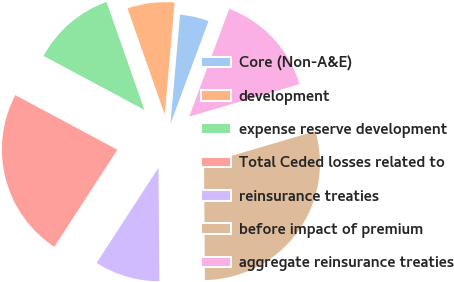Convert chart. <chart><loc_0><loc_0><loc_500><loc_500><pie_chart><fcel>Core (Non-A&E)<fcel>development<fcel>expense reserve development<fcel>Total Ceded losses related to<fcel>reinsurance treaties<fcel>before impact of premium<fcel>aggregate reinsurance treaties<nl><fcel>4.25%<fcel>6.77%<fcel>11.81%<fcel>23.65%<fcel>9.29%<fcel>29.43%<fcel>14.8%<nl></chart> 